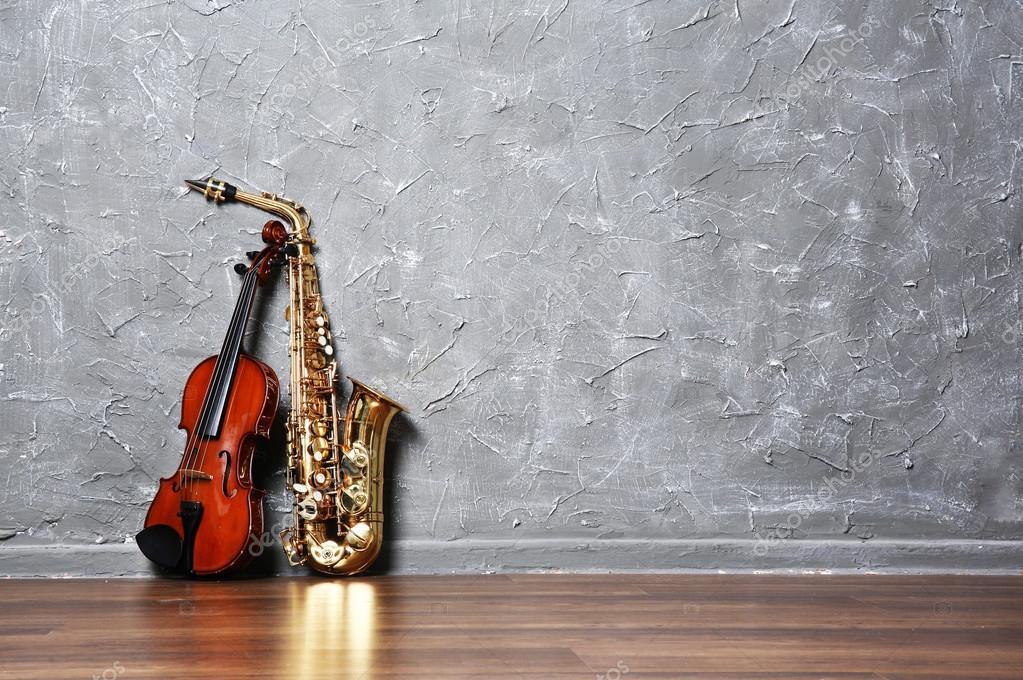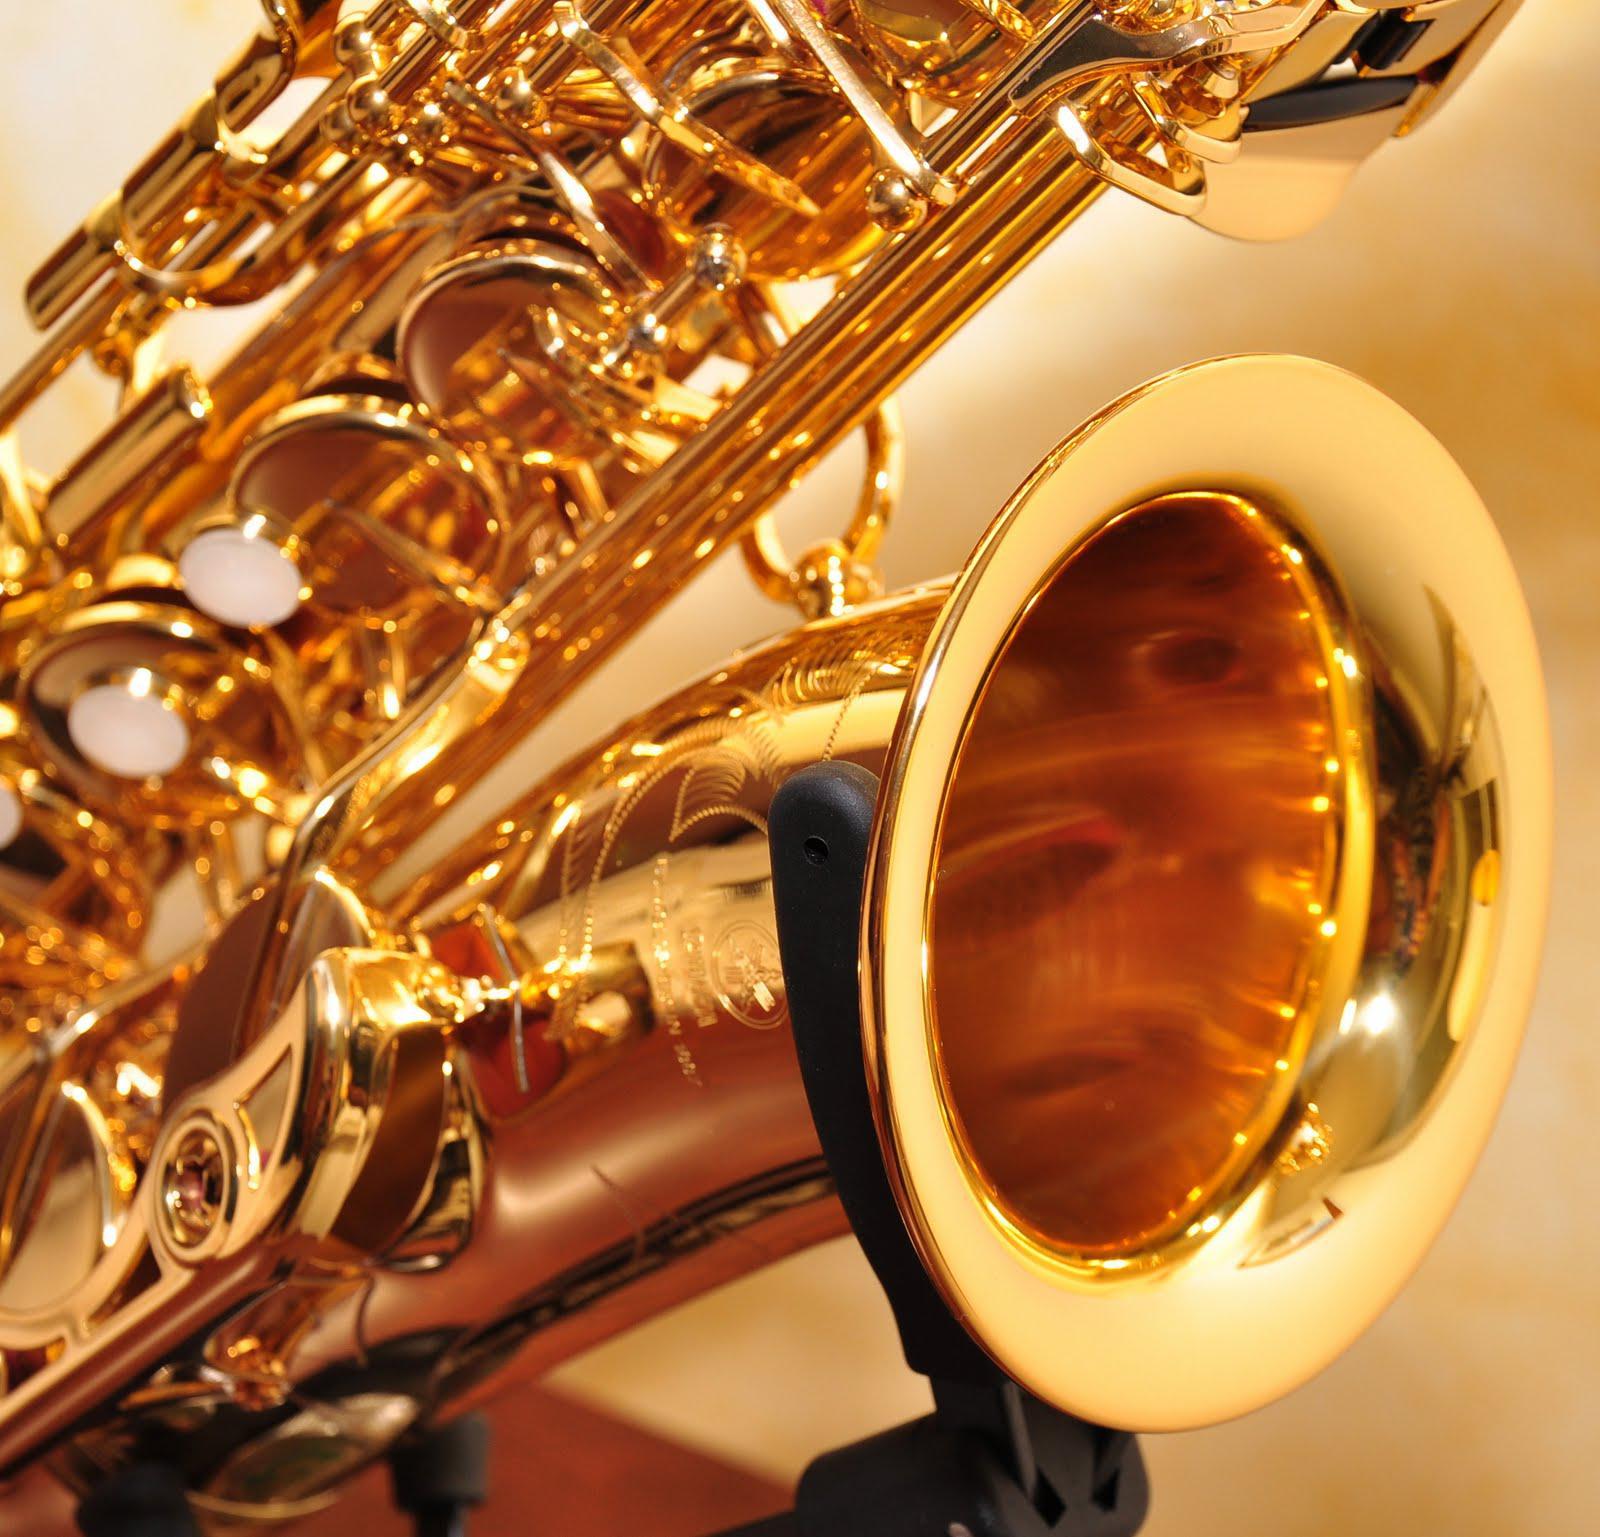The first image is the image on the left, the second image is the image on the right. For the images shown, is this caption "Both images contain three instruments." true? Answer yes or no. No. 